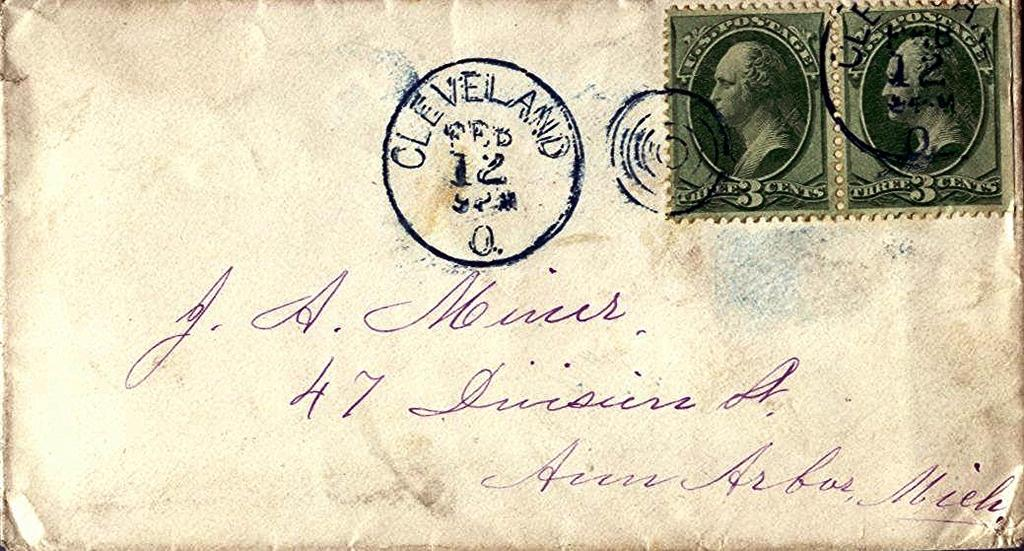Provide a one-sentence caption for the provided image. A letter is postmarked as being sent from Cleveland. 